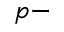Convert formula to latex. <formula><loc_0><loc_0><loc_500><loc_500>p -</formula> 